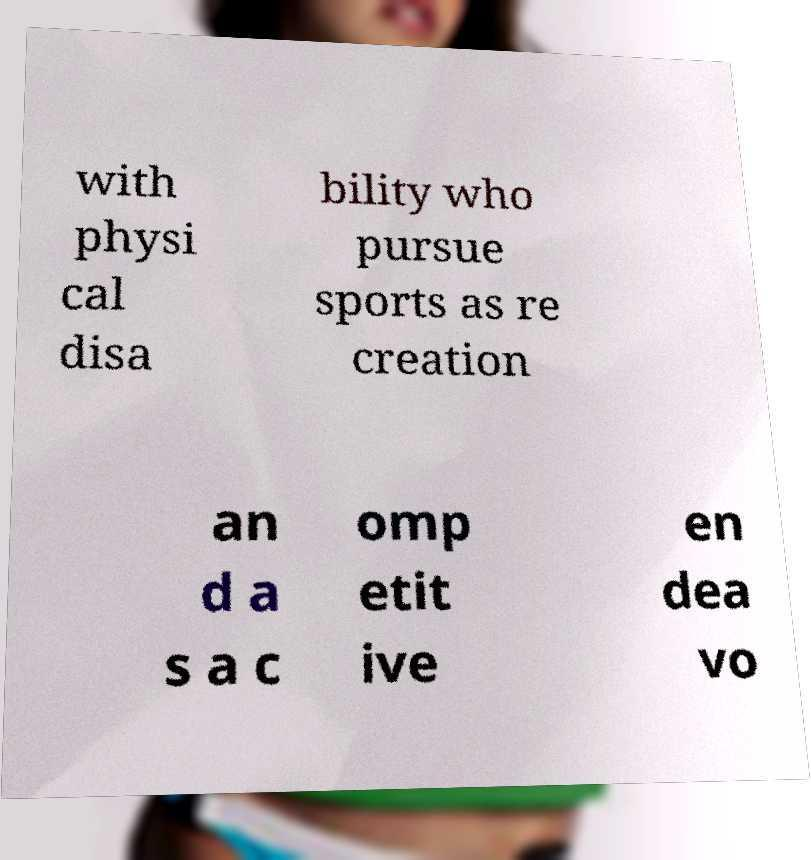Please read and relay the text visible in this image. What does it say? with physi cal disa bility who pursue sports as re creation an d a s a c omp etit ive en dea vo 